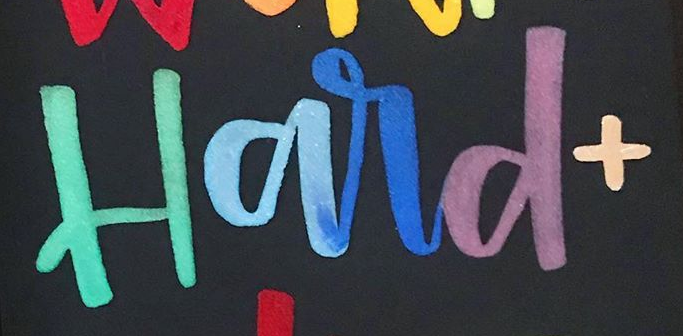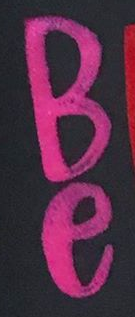What words are shown in these images in order, separated by a semicolon? Hard+; Be 